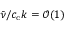Convert formula to latex. <formula><loc_0><loc_0><loc_500><loc_500>\bar { \nu } / c _ { c } k = \mathcal { O } ( 1 )</formula> 